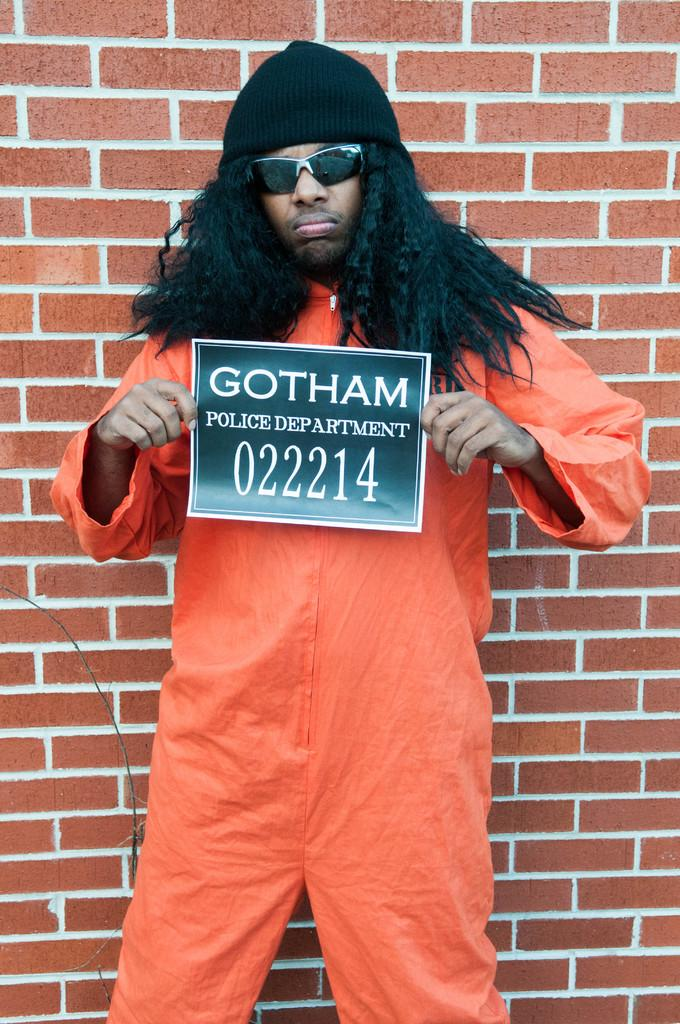What is the main subject of the image? There is a person standing in the image. What is the person doing in the image? The person is standing on the ground and holding a poster. What can be seen in the background of the image? There is a brick wall in the background of the image. Can you tell me how many stems are visible on the goat in the image? There is no goat present in the image, so there are no stems to count. 